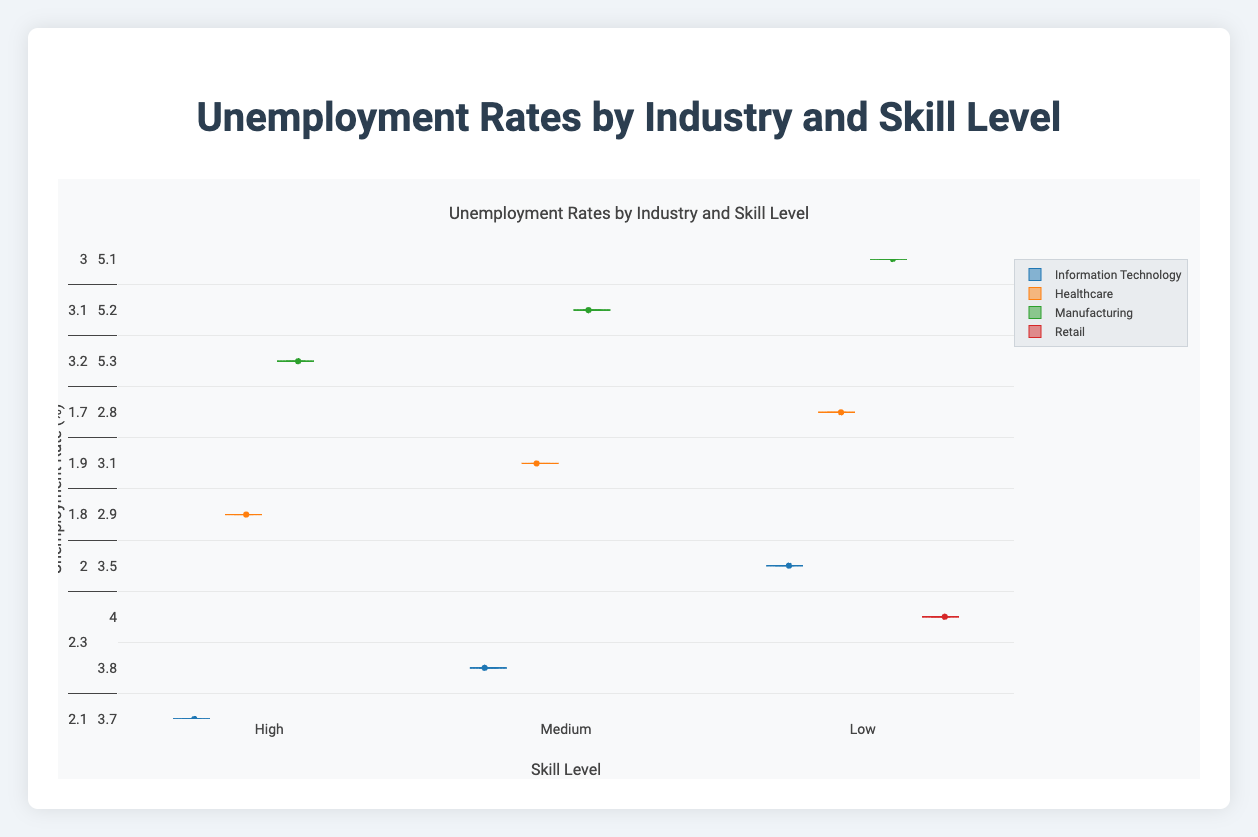What's the overall title of the figure? The title is located at the top of the figure and typically summarizes the information being displayed.
Answer: Unemployment Rates by Industry and Skill Level Which industry has the lowest unemployment rate for high skill levels? Look at the box plots grouped under "High" skill levels across different industries. Identify the industry with the box plot closest to the bottom of the chart (lowest values).
Answer: Healthcare What is the median unemployment rate for low skill levels in the Manufacturing industry? Find the box plot for Manufacturing under "Low" skill level. The median is the line that divides the box into two equal parts.
Answer: 7.6% Which skill level in the Retail industry has the highest unemployment rate? Examine the box plots under the Retail industry. Locate the highest box (whisker upper end). Compare all three skill levels (High, Medium, Low).
Answer: Low Compare the median unemployment rates between high and low skill levels in the Information Technology industry. Find the median lines within the boxes for both "High" and "Low" skill levels under Information Technology. Subtract the median of the high skill level from the median of the low skill level.
Answer: 3.0% Which industry generally has the largest spread in unemployment rates for medium skill levels? Identify the box plots under the "Medium" skill level for all industries. The spread can be measured by the distance between the bottom and top whiskers.
Answer: Manufacturing What can you infer about the unemployment rates for high skill levels across different industries? Observe the box plots for the "High" skill level across all industries. Notice their positions and spreads. They generally show lower and more consistent unemployment rates compared to medium and low skill levels.
Answer: Lower and more consistent How does the unemployment rate range for low skill levels in Manufacturing compare to the same level in Healthcare? Locate the box plots for "Low" skill levels in both Manufacturing and Healthcare. Compare the range by looking at the distance between the whiskers (minimum and maximum values).
Answer: Higher in Manufacturing What is the most significant trend you observe between skill levels and unemployment rates? Examine the overall pattern for each skill level within industries. Notice how the unemployment rates tend to rise as the skill level decreases across most industries.
Answer: Unemployment rates increase as skill levels decrease 